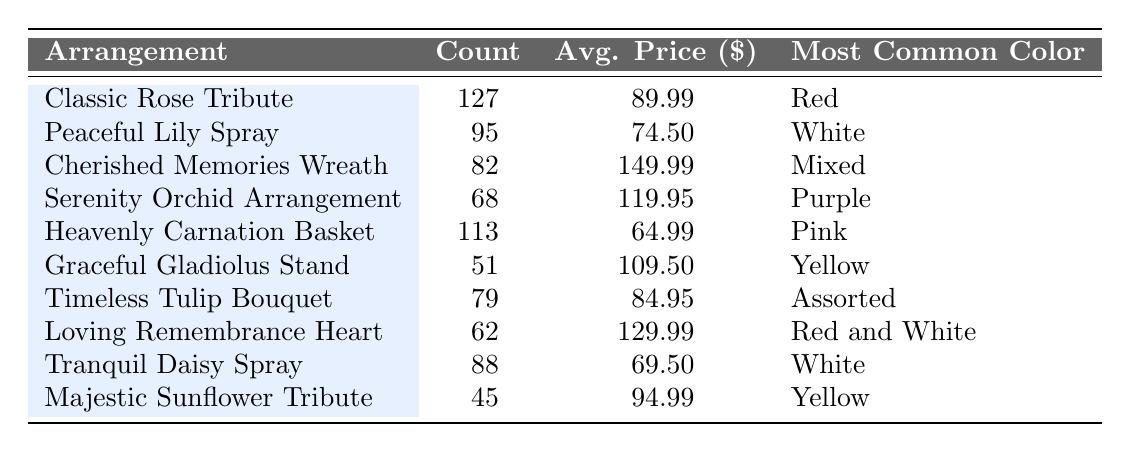What is the most ordered flower arrangement? The table shows the "Count" of each flower arrangement. The highest count is 127 for the "Classic Rose Tribute," which indicates it is the most ordered flower arrangement.
Answer: Classic Rose Tribute How many Peaceful Lily Sprays were ordered? By looking at the "Count" column, the number of "Peaceful Lily Spray" orders is stated as 95.
Answer: 95 What is the average price of the Loving Remembrance Heart? The table lists the average price of the "Loving Remembrance Heart" as 129.99, which directly answers the question.
Answer: 129.99 Which flower arrangement has the lowest order count? When examining the "Count" data, "Majestic Sunflower Tribute" has the lowest count with 45 orders.
Answer: Majestic Sunflower Tribute What are the most common colors for flower arrangements? The "Most Common Color" column includes various colors such as Red, White, Mixed, Purple, Pink, Yellow, Assorted, and Red and White. The arrangements feature a variety of colors.
Answer: Red, White, Mixed, Purple, Pink, Yellow, Assorted, Red and White If I wanted to know the total count of floral arrangements ordered, what would that be? To find the total count, sum all the "Count" values: 127 + 95 + 82 + 68 + 113 + 51 + 79 + 62 + 88 + 45 = 828. Therefore, the total count is 828.
Answer: 828 How much more expensive, on average, is the Cherished Memories Wreath compared to the Heavenly Carnation Basket? The average price of the "Cherished Memories Wreath" is 149.99, while the average price of the "Heavenly Carnation Basket" is 64.99. The difference is 149.99 - 64.99 = 85.00, indicating that the wreath is on average $85 more expensive.
Answer: 85.00 Are there any arrangements for which the most common color is Yellow? The "Most Common Color" for "Graceful Gladiolus Stand" and "Majestic Sunflower Tribute" is Yellow, indicating that yes, there are arrangements with that common color.
Answer: Yes Which flower arrangement has the highest average price, and what is that price? The highest average price is for the "Cherished Memories Wreath" at 149.99, according to the "Avg. Price" column.
Answer: Cherished Memories Wreath, 149.99 What is the total count of flower arrangements with the common color White? The arrangements with the common color White are "Peaceful Lily Spray" (95) and "Tranquil Daisy Spray" (88). Summing these gives 95 + 88 = 183.
Answer: 183 